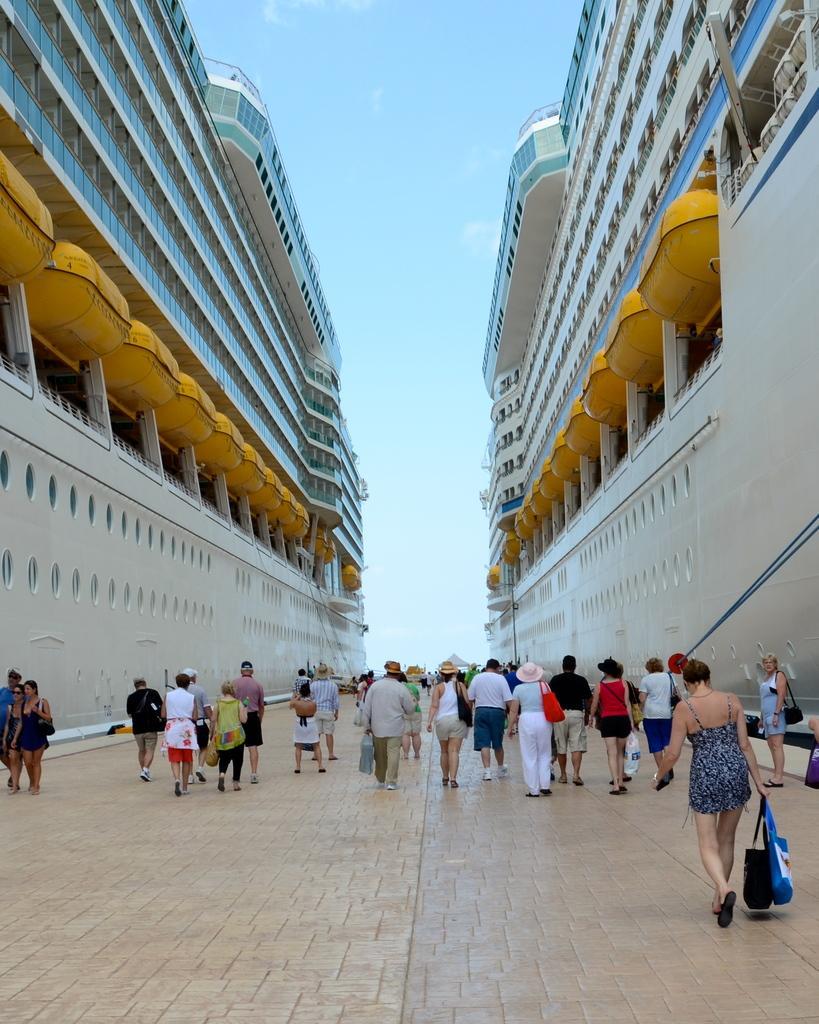In one or two sentences, can you explain what this image depicts? As we can see in the image there are buildings, group of people and sky. The woman walking on the right side is wearing black color dress and holding bag. 